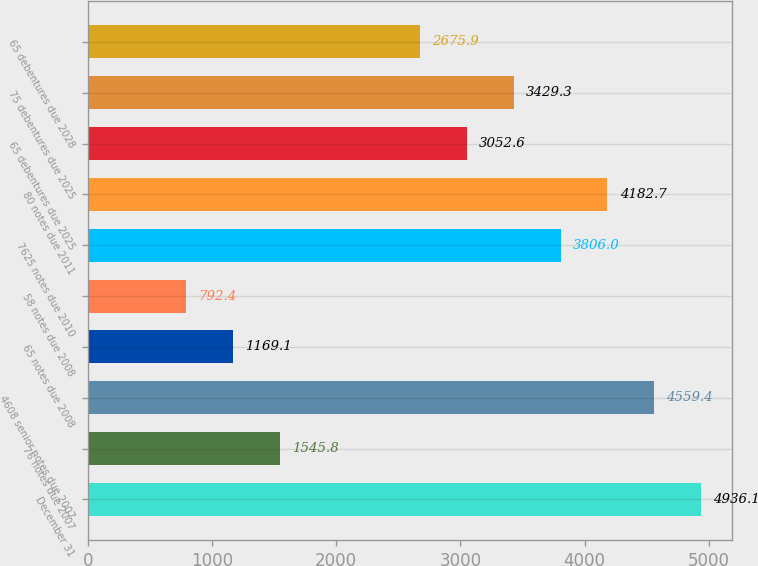Convert chart to OTSL. <chart><loc_0><loc_0><loc_500><loc_500><bar_chart><fcel>December 31<fcel>76 notes due 2007<fcel>4608 senior notes due 2007<fcel>65 notes due 2008<fcel>58 notes due 2008<fcel>7625 notes due 2010<fcel>80 notes due 2011<fcel>65 debentures due 2025<fcel>75 debentures due 2025<fcel>65 debentures due 2028<nl><fcel>4936.1<fcel>1545.8<fcel>4559.4<fcel>1169.1<fcel>792.4<fcel>3806<fcel>4182.7<fcel>3052.6<fcel>3429.3<fcel>2675.9<nl></chart> 